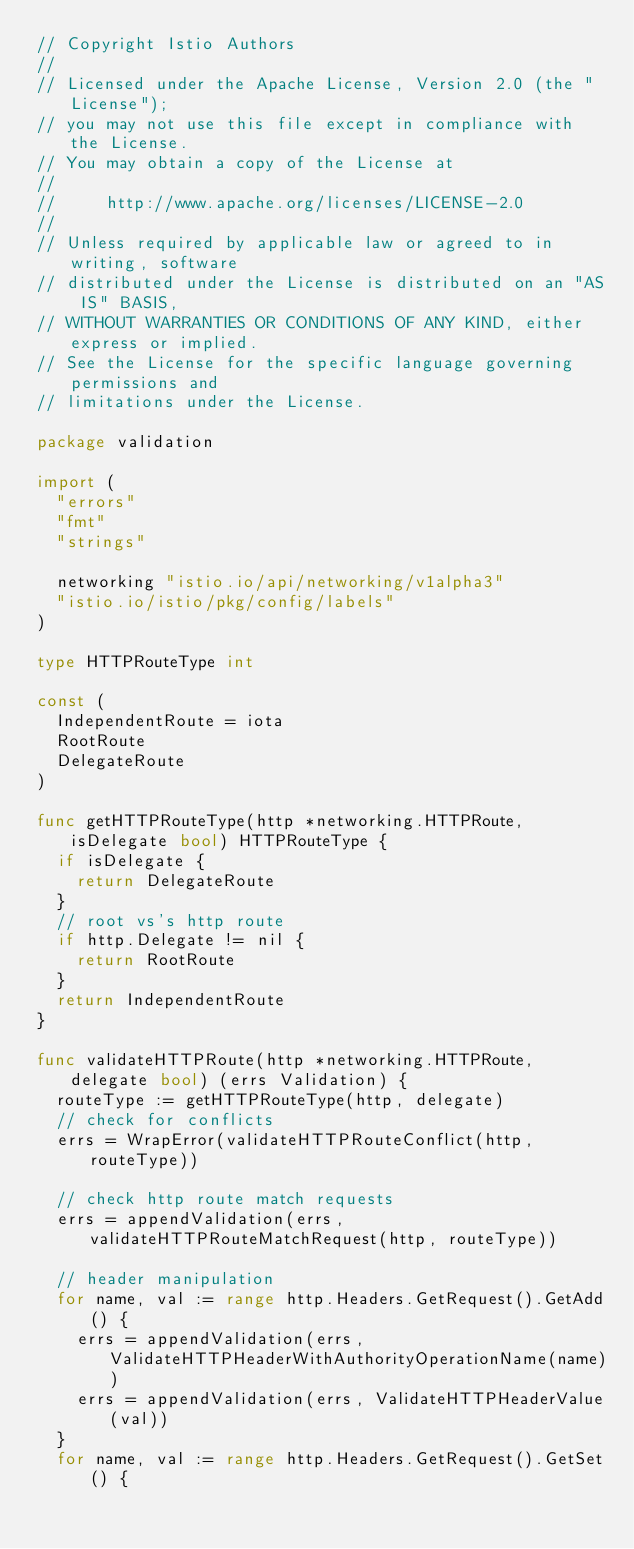Convert code to text. <code><loc_0><loc_0><loc_500><loc_500><_Go_>// Copyright Istio Authors
//
// Licensed under the Apache License, Version 2.0 (the "License");
// you may not use this file except in compliance with the License.
// You may obtain a copy of the License at
//
//     http://www.apache.org/licenses/LICENSE-2.0
//
// Unless required by applicable law or agreed to in writing, software
// distributed under the License is distributed on an "AS IS" BASIS,
// WITHOUT WARRANTIES OR CONDITIONS OF ANY KIND, either express or implied.
// See the License for the specific language governing permissions and
// limitations under the License.

package validation

import (
	"errors"
	"fmt"
	"strings"

	networking "istio.io/api/networking/v1alpha3"
	"istio.io/istio/pkg/config/labels"
)

type HTTPRouteType int

const (
	IndependentRoute = iota
	RootRoute
	DelegateRoute
)

func getHTTPRouteType(http *networking.HTTPRoute, isDelegate bool) HTTPRouteType {
	if isDelegate {
		return DelegateRoute
	}
	// root vs's http route
	if http.Delegate != nil {
		return RootRoute
	}
	return IndependentRoute
}

func validateHTTPRoute(http *networking.HTTPRoute, delegate bool) (errs Validation) {
	routeType := getHTTPRouteType(http, delegate)
	// check for conflicts
	errs = WrapError(validateHTTPRouteConflict(http, routeType))

	// check http route match requests
	errs = appendValidation(errs, validateHTTPRouteMatchRequest(http, routeType))

	// header manipulation
	for name, val := range http.Headers.GetRequest().GetAdd() {
		errs = appendValidation(errs, ValidateHTTPHeaderWithAuthorityOperationName(name))
		errs = appendValidation(errs, ValidateHTTPHeaderValue(val))
	}
	for name, val := range http.Headers.GetRequest().GetSet() {</code> 